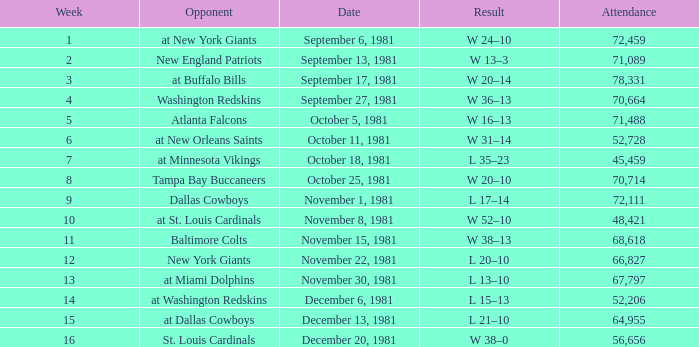What is the Attendance, when the Opponent is the Tampa Bay Buccaneers? 70714.0. 